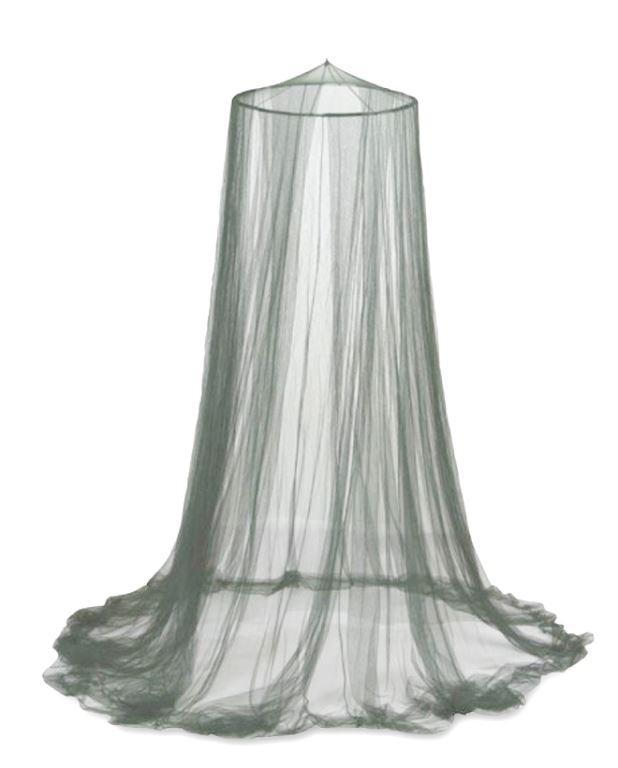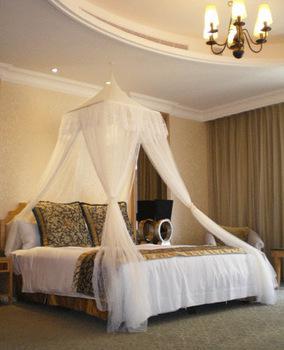The first image is the image on the left, the second image is the image on the right. Examine the images to the left and right. Is the description "There are two canopies that cover a mattress." accurate? Answer yes or no. No. The first image is the image on the left, the second image is the image on the right. Given the left and right images, does the statement "There are two beds." hold true? Answer yes or no. No. 